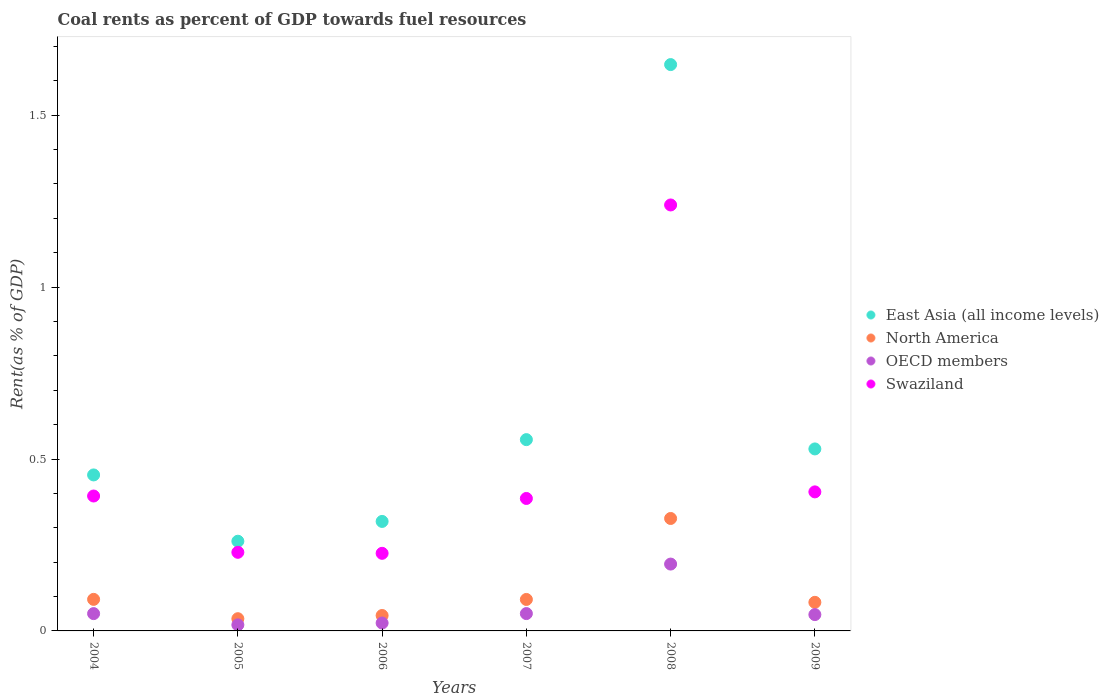How many different coloured dotlines are there?
Offer a very short reply. 4. What is the coal rent in North America in 2005?
Make the answer very short. 0.04. Across all years, what is the maximum coal rent in OECD members?
Offer a very short reply. 0.19. Across all years, what is the minimum coal rent in North America?
Offer a very short reply. 0.04. In which year was the coal rent in East Asia (all income levels) maximum?
Offer a very short reply. 2008. In which year was the coal rent in North America minimum?
Keep it short and to the point. 2005. What is the total coal rent in OECD members in the graph?
Keep it short and to the point. 0.38. What is the difference between the coal rent in OECD members in 2005 and that in 2006?
Offer a terse response. -0.01. What is the difference between the coal rent in Swaziland in 2004 and the coal rent in East Asia (all income levels) in 2007?
Your response must be concise. -0.16. What is the average coal rent in OECD members per year?
Your answer should be compact. 0.06. In the year 2004, what is the difference between the coal rent in East Asia (all income levels) and coal rent in Swaziland?
Provide a succinct answer. 0.06. In how many years, is the coal rent in East Asia (all income levels) greater than 1.1 %?
Offer a terse response. 1. What is the ratio of the coal rent in East Asia (all income levels) in 2007 to that in 2008?
Ensure brevity in your answer.  0.34. Is the coal rent in OECD members in 2007 less than that in 2009?
Your response must be concise. No. Is the difference between the coal rent in East Asia (all income levels) in 2005 and 2007 greater than the difference between the coal rent in Swaziland in 2005 and 2007?
Your response must be concise. No. What is the difference between the highest and the second highest coal rent in North America?
Provide a short and direct response. 0.24. What is the difference between the highest and the lowest coal rent in East Asia (all income levels)?
Your answer should be very brief. 1.39. Is the sum of the coal rent in OECD members in 2004 and 2007 greater than the maximum coal rent in East Asia (all income levels) across all years?
Offer a terse response. No. Is it the case that in every year, the sum of the coal rent in North America and coal rent in OECD members  is greater than the sum of coal rent in East Asia (all income levels) and coal rent in Swaziland?
Keep it short and to the point. No. Is it the case that in every year, the sum of the coal rent in North America and coal rent in Swaziland  is greater than the coal rent in East Asia (all income levels)?
Keep it short and to the point. No. Does the coal rent in North America monotonically increase over the years?
Your answer should be very brief. No. Is the coal rent in Swaziland strictly less than the coal rent in East Asia (all income levels) over the years?
Your response must be concise. Yes. How many dotlines are there?
Ensure brevity in your answer.  4. How many years are there in the graph?
Offer a terse response. 6. Are the values on the major ticks of Y-axis written in scientific E-notation?
Your response must be concise. No. Where does the legend appear in the graph?
Keep it short and to the point. Center right. How many legend labels are there?
Provide a succinct answer. 4. How are the legend labels stacked?
Provide a succinct answer. Vertical. What is the title of the graph?
Provide a succinct answer. Coal rents as percent of GDP towards fuel resources. What is the label or title of the Y-axis?
Your answer should be very brief. Rent(as % of GDP). What is the Rent(as % of GDP) of East Asia (all income levels) in 2004?
Provide a short and direct response. 0.45. What is the Rent(as % of GDP) in North America in 2004?
Provide a succinct answer. 0.09. What is the Rent(as % of GDP) of OECD members in 2004?
Provide a short and direct response. 0.05. What is the Rent(as % of GDP) of Swaziland in 2004?
Give a very brief answer. 0.39. What is the Rent(as % of GDP) in East Asia (all income levels) in 2005?
Make the answer very short. 0.26. What is the Rent(as % of GDP) of North America in 2005?
Your response must be concise. 0.04. What is the Rent(as % of GDP) in OECD members in 2005?
Give a very brief answer. 0.02. What is the Rent(as % of GDP) in Swaziland in 2005?
Your answer should be very brief. 0.23. What is the Rent(as % of GDP) in East Asia (all income levels) in 2006?
Provide a succinct answer. 0.32. What is the Rent(as % of GDP) in North America in 2006?
Your answer should be compact. 0.04. What is the Rent(as % of GDP) of OECD members in 2006?
Your answer should be compact. 0.02. What is the Rent(as % of GDP) in Swaziland in 2006?
Provide a succinct answer. 0.23. What is the Rent(as % of GDP) in East Asia (all income levels) in 2007?
Offer a very short reply. 0.56. What is the Rent(as % of GDP) of North America in 2007?
Make the answer very short. 0.09. What is the Rent(as % of GDP) in OECD members in 2007?
Offer a very short reply. 0.05. What is the Rent(as % of GDP) in Swaziland in 2007?
Offer a terse response. 0.39. What is the Rent(as % of GDP) in East Asia (all income levels) in 2008?
Keep it short and to the point. 1.65. What is the Rent(as % of GDP) of North America in 2008?
Your response must be concise. 0.33. What is the Rent(as % of GDP) in OECD members in 2008?
Provide a succinct answer. 0.19. What is the Rent(as % of GDP) of Swaziland in 2008?
Make the answer very short. 1.24. What is the Rent(as % of GDP) of East Asia (all income levels) in 2009?
Give a very brief answer. 0.53. What is the Rent(as % of GDP) in North America in 2009?
Offer a very short reply. 0.08. What is the Rent(as % of GDP) of OECD members in 2009?
Offer a very short reply. 0.05. What is the Rent(as % of GDP) of Swaziland in 2009?
Keep it short and to the point. 0.4. Across all years, what is the maximum Rent(as % of GDP) in East Asia (all income levels)?
Your answer should be compact. 1.65. Across all years, what is the maximum Rent(as % of GDP) of North America?
Offer a terse response. 0.33. Across all years, what is the maximum Rent(as % of GDP) of OECD members?
Give a very brief answer. 0.19. Across all years, what is the maximum Rent(as % of GDP) in Swaziland?
Provide a short and direct response. 1.24. Across all years, what is the minimum Rent(as % of GDP) in East Asia (all income levels)?
Your answer should be very brief. 0.26. Across all years, what is the minimum Rent(as % of GDP) of North America?
Provide a short and direct response. 0.04. Across all years, what is the minimum Rent(as % of GDP) in OECD members?
Make the answer very short. 0.02. Across all years, what is the minimum Rent(as % of GDP) of Swaziland?
Your answer should be compact. 0.23. What is the total Rent(as % of GDP) of East Asia (all income levels) in the graph?
Provide a short and direct response. 3.77. What is the total Rent(as % of GDP) of North America in the graph?
Your answer should be very brief. 0.67. What is the total Rent(as % of GDP) in OECD members in the graph?
Make the answer very short. 0.38. What is the total Rent(as % of GDP) in Swaziland in the graph?
Your answer should be compact. 2.88. What is the difference between the Rent(as % of GDP) of East Asia (all income levels) in 2004 and that in 2005?
Your response must be concise. 0.19. What is the difference between the Rent(as % of GDP) of North America in 2004 and that in 2005?
Provide a short and direct response. 0.06. What is the difference between the Rent(as % of GDP) in OECD members in 2004 and that in 2005?
Provide a succinct answer. 0.03. What is the difference between the Rent(as % of GDP) in Swaziland in 2004 and that in 2005?
Your answer should be very brief. 0.16. What is the difference between the Rent(as % of GDP) in East Asia (all income levels) in 2004 and that in 2006?
Provide a succinct answer. 0.14. What is the difference between the Rent(as % of GDP) in North America in 2004 and that in 2006?
Ensure brevity in your answer.  0.05. What is the difference between the Rent(as % of GDP) of OECD members in 2004 and that in 2006?
Offer a terse response. 0.03. What is the difference between the Rent(as % of GDP) in Swaziland in 2004 and that in 2006?
Ensure brevity in your answer.  0.17. What is the difference between the Rent(as % of GDP) of East Asia (all income levels) in 2004 and that in 2007?
Give a very brief answer. -0.1. What is the difference between the Rent(as % of GDP) in OECD members in 2004 and that in 2007?
Provide a short and direct response. -0. What is the difference between the Rent(as % of GDP) in Swaziland in 2004 and that in 2007?
Give a very brief answer. 0.01. What is the difference between the Rent(as % of GDP) of East Asia (all income levels) in 2004 and that in 2008?
Your answer should be very brief. -1.19. What is the difference between the Rent(as % of GDP) of North America in 2004 and that in 2008?
Make the answer very short. -0.24. What is the difference between the Rent(as % of GDP) in OECD members in 2004 and that in 2008?
Provide a succinct answer. -0.14. What is the difference between the Rent(as % of GDP) of Swaziland in 2004 and that in 2008?
Provide a short and direct response. -0.85. What is the difference between the Rent(as % of GDP) of East Asia (all income levels) in 2004 and that in 2009?
Offer a very short reply. -0.08. What is the difference between the Rent(as % of GDP) of North America in 2004 and that in 2009?
Ensure brevity in your answer.  0.01. What is the difference between the Rent(as % of GDP) of OECD members in 2004 and that in 2009?
Keep it short and to the point. 0. What is the difference between the Rent(as % of GDP) in Swaziland in 2004 and that in 2009?
Offer a very short reply. -0.01. What is the difference between the Rent(as % of GDP) in East Asia (all income levels) in 2005 and that in 2006?
Offer a terse response. -0.06. What is the difference between the Rent(as % of GDP) in North America in 2005 and that in 2006?
Your response must be concise. -0.01. What is the difference between the Rent(as % of GDP) in OECD members in 2005 and that in 2006?
Make the answer very short. -0.01. What is the difference between the Rent(as % of GDP) of Swaziland in 2005 and that in 2006?
Keep it short and to the point. 0. What is the difference between the Rent(as % of GDP) of East Asia (all income levels) in 2005 and that in 2007?
Offer a terse response. -0.3. What is the difference between the Rent(as % of GDP) in North America in 2005 and that in 2007?
Ensure brevity in your answer.  -0.06. What is the difference between the Rent(as % of GDP) of OECD members in 2005 and that in 2007?
Keep it short and to the point. -0.03. What is the difference between the Rent(as % of GDP) in Swaziland in 2005 and that in 2007?
Your answer should be very brief. -0.16. What is the difference between the Rent(as % of GDP) of East Asia (all income levels) in 2005 and that in 2008?
Provide a short and direct response. -1.39. What is the difference between the Rent(as % of GDP) in North America in 2005 and that in 2008?
Your answer should be compact. -0.29. What is the difference between the Rent(as % of GDP) of OECD members in 2005 and that in 2008?
Your answer should be compact. -0.18. What is the difference between the Rent(as % of GDP) of Swaziland in 2005 and that in 2008?
Keep it short and to the point. -1.01. What is the difference between the Rent(as % of GDP) of East Asia (all income levels) in 2005 and that in 2009?
Ensure brevity in your answer.  -0.27. What is the difference between the Rent(as % of GDP) of North America in 2005 and that in 2009?
Provide a succinct answer. -0.05. What is the difference between the Rent(as % of GDP) in OECD members in 2005 and that in 2009?
Offer a terse response. -0.03. What is the difference between the Rent(as % of GDP) in Swaziland in 2005 and that in 2009?
Your answer should be compact. -0.18. What is the difference between the Rent(as % of GDP) in East Asia (all income levels) in 2006 and that in 2007?
Your response must be concise. -0.24. What is the difference between the Rent(as % of GDP) of North America in 2006 and that in 2007?
Make the answer very short. -0.05. What is the difference between the Rent(as % of GDP) in OECD members in 2006 and that in 2007?
Offer a very short reply. -0.03. What is the difference between the Rent(as % of GDP) of Swaziland in 2006 and that in 2007?
Your answer should be compact. -0.16. What is the difference between the Rent(as % of GDP) in East Asia (all income levels) in 2006 and that in 2008?
Offer a terse response. -1.33. What is the difference between the Rent(as % of GDP) of North America in 2006 and that in 2008?
Provide a short and direct response. -0.28. What is the difference between the Rent(as % of GDP) in OECD members in 2006 and that in 2008?
Give a very brief answer. -0.17. What is the difference between the Rent(as % of GDP) in Swaziland in 2006 and that in 2008?
Offer a terse response. -1.01. What is the difference between the Rent(as % of GDP) of East Asia (all income levels) in 2006 and that in 2009?
Offer a terse response. -0.21. What is the difference between the Rent(as % of GDP) in North America in 2006 and that in 2009?
Offer a very short reply. -0.04. What is the difference between the Rent(as % of GDP) in OECD members in 2006 and that in 2009?
Offer a terse response. -0.02. What is the difference between the Rent(as % of GDP) of Swaziland in 2006 and that in 2009?
Provide a short and direct response. -0.18. What is the difference between the Rent(as % of GDP) of East Asia (all income levels) in 2007 and that in 2008?
Make the answer very short. -1.09. What is the difference between the Rent(as % of GDP) of North America in 2007 and that in 2008?
Make the answer very short. -0.24. What is the difference between the Rent(as % of GDP) of OECD members in 2007 and that in 2008?
Your answer should be very brief. -0.14. What is the difference between the Rent(as % of GDP) of Swaziland in 2007 and that in 2008?
Keep it short and to the point. -0.85. What is the difference between the Rent(as % of GDP) in East Asia (all income levels) in 2007 and that in 2009?
Keep it short and to the point. 0.03. What is the difference between the Rent(as % of GDP) in North America in 2007 and that in 2009?
Offer a terse response. 0.01. What is the difference between the Rent(as % of GDP) in OECD members in 2007 and that in 2009?
Provide a short and direct response. 0. What is the difference between the Rent(as % of GDP) in Swaziland in 2007 and that in 2009?
Your response must be concise. -0.02. What is the difference between the Rent(as % of GDP) in East Asia (all income levels) in 2008 and that in 2009?
Keep it short and to the point. 1.12. What is the difference between the Rent(as % of GDP) of North America in 2008 and that in 2009?
Make the answer very short. 0.24. What is the difference between the Rent(as % of GDP) in OECD members in 2008 and that in 2009?
Your answer should be very brief. 0.15. What is the difference between the Rent(as % of GDP) of Swaziland in 2008 and that in 2009?
Your answer should be very brief. 0.83. What is the difference between the Rent(as % of GDP) of East Asia (all income levels) in 2004 and the Rent(as % of GDP) of North America in 2005?
Ensure brevity in your answer.  0.42. What is the difference between the Rent(as % of GDP) of East Asia (all income levels) in 2004 and the Rent(as % of GDP) of OECD members in 2005?
Offer a terse response. 0.44. What is the difference between the Rent(as % of GDP) of East Asia (all income levels) in 2004 and the Rent(as % of GDP) of Swaziland in 2005?
Your answer should be very brief. 0.23. What is the difference between the Rent(as % of GDP) of North America in 2004 and the Rent(as % of GDP) of OECD members in 2005?
Give a very brief answer. 0.07. What is the difference between the Rent(as % of GDP) in North America in 2004 and the Rent(as % of GDP) in Swaziland in 2005?
Provide a succinct answer. -0.14. What is the difference between the Rent(as % of GDP) in OECD members in 2004 and the Rent(as % of GDP) in Swaziland in 2005?
Keep it short and to the point. -0.18. What is the difference between the Rent(as % of GDP) of East Asia (all income levels) in 2004 and the Rent(as % of GDP) of North America in 2006?
Give a very brief answer. 0.41. What is the difference between the Rent(as % of GDP) of East Asia (all income levels) in 2004 and the Rent(as % of GDP) of OECD members in 2006?
Make the answer very short. 0.43. What is the difference between the Rent(as % of GDP) of East Asia (all income levels) in 2004 and the Rent(as % of GDP) of Swaziland in 2006?
Give a very brief answer. 0.23. What is the difference between the Rent(as % of GDP) in North America in 2004 and the Rent(as % of GDP) in OECD members in 2006?
Give a very brief answer. 0.07. What is the difference between the Rent(as % of GDP) in North America in 2004 and the Rent(as % of GDP) in Swaziland in 2006?
Your answer should be compact. -0.13. What is the difference between the Rent(as % of GDP) of OECD members in 2004 and the Rent(as % of GDP) of Swaziland in 2006?
Ensure brevity in your answer.  -0.18. What is the difference between the Rent(as % of GDP) in East Asia (all income levels) in 2004 and the Rent(as % of GDP) in North America in 2007?
Your answer should be compact. 0.36. What is the difference between the Rent(as % of GDP) in East Asia (all income levels) in 2004 and the Rent(as % of GDP) in OECD members in 2007?
Ensure brevity in your answer.  0.4. What is the difference between the Rent(as % of GDP) in East Asia (all income levels) in 2004 and the Rent(as % of GDP) in Swaziland in 2007?
Make the answer very short. 0.07. What is the difference between the Rent(as % of GDP) of North America in 2004 and the Rent(as % of GDP) of OECD members in 2007?
Offer a very short reply. 0.04. What is the difference between the Rent(as % of GDP) of North America in 2004 and the Rent(as % of GDP) of Swaziland in 2007?
Keep it short and to the point. -0.29. What is the difference between the Rent(as % of GDP) in OECD members in 2004 and the Rent(as % of GDP) in Swaziland in 2007?
Ensure brevity in your answer.  -0.33. What is the difference between the Rent(as % of GDP) of East Asia (all income levels) in 2004 and the Rent(as % of GDP) of North America in 2008?
Provide a succinct answer. 0.13. What is the difference between the Rent(as % of GDP) of East Asia (all income levels) in 2004 and the Rent(as % of GDP) of OECD members in 2008?
Provide a short and direct response. 0.26. What is the difference between the Rent(as % of GDP) of East Asia (all income levels) in 2004 and the Rent(as % of GDP) of Swaziland in 2008?
Offer a terse response. -0.79. What is the difference between the Rent(as % of GDP) of North America in 2004 and the Rent(as % of GDP) of OECD members in 2008?
Your answer should be very brief. -0.1. What is the difference between the Rent(as % of GDP) in North America in 2004 and the Rent(as % of GDP) in Swaziland in 2008?
Offer a terse response. -1.15. What is the difference between the Rent(as % of GDP) in OECD members in 2004 and the Rent(as % of GDP) in Swaziland in 2008?
Offer a terse response. -1.19. What is the difference between the Rent(as % of GDP) of East Asia (all income levels) in 2004 and the Rent(as % of GDP) of North America in 2009?
Your answer should be compact. 0.37. What is the difference between the Rent(as % of GDP) in East Asia (all income levels) in 2004 and the Rent(as % of GDP) in OECD members in 2009?
Provide a short and direct response. 0.41. What is the difference between the Rent(as % of GDP) in East Asia (all income levels) in 2004 and the Rent(as % of GDP) in Swaziland in 2009?
Offer a very short reply. 0.05. What is the difference between the Rent(as % of GDP) in North America in 2004 and the Rent(as % of GDP) in OECD members in 2009?
Offer a very short reply. 0.04. What is the difference between the Rent(as % of GDP) of North America in 2004 and the Rent(as % of GDP) of Swaziland in 2009?
Your response must be concise. -0.31. What is the difference between the Rent(as % of GDP) in OECD members in 2004 and the Rent(as % of GDP) in Swaziland in 2009?
Keep it short and to the point. -0.35. What is the difference between the Rent(as % of GDP) of East Asia (all income levels) in 2005 and the Rent(as % of GDP) of North America in 2006?
Your answer should be very brief. 0.22. What is the difference between the Rent(as % of GDP) in East Asia (all income levels) in 2005 and the Rent(as % of GDP) in OECD members in 2006?
Your response must be concise. 0.24. What is the difference between the Rent(as % of GDP) of East Asia (all income levels) in 2005 and the Rent(as % of GDP) of Swaziland in 2006?
Make the answer very short. 0.04. What is the difference between the Rent(as % of GDP) in North America in 2005 and the Rent(as % of GDP) in OECD members in 2006?
Offer a terse response. 0.01. What is the difference between the Rent(as % of GDP) in North America in 2005 and the Rent(as % of GDP) in Swaziland in 2006?
Give a very brief answer. -0.19. What is the difference between the Rent(as % of GDP) of OECD members in 2005 and the Rent(as % of GDP) of Swaziland in 2006?
Your answer should be very brief. -0.21. What is the difference between the Rent(as % of GDP) of East Asia (all income levels) in 2005 and the Rent(as % of GDP) of North America in 2007?
Provide a succinct answer. 0.17. What is the difference between the Rent(as % of GDP) in East Asia (all income levels) in 2005 and the Rent(as % of GDP) in OECD members in 2007?
Give a very brief answer. 0.21. What is the difference between the Rent(as % of GDP) of East Asia (all income levels) in 2005 and the Rent(as % of GDP) of Swaziland in 2007?
Offer a very short reply. -0.12. What is the difference between the Rent(as % of GDP) in North America in 2005 and the Rent(as % of GDP) in OECD members in 2007?
Provide a short and direct response. -0.01. What is the difference between the Rent(as % of GDP) in North America in 2005 and the Rent(as % of GDP) in Swaziland in 2007?
Offer a terse response. -0.35. What is the difference between the Rent(as % of GDP) of OECD members in 2005 and the Rent(as % of GDP) of Swaziland in 2007?
Your answer should be very brief. -0.37. What is the difference between the Rent(as % of GDP) in East Asia (all income levels) in 2005 and the Rent(as % of GDP) in North America in 2008?
Keep it short and to the point. -0.07. What is the difference between the Rent(as % of GDP) of East Asia (all income levels) in 2005 and the Rent(as % of GDP) of OECD members in 2008?
Your answer should be very brief. 0.07. What is the difference between the Rent(as % of GDP) of East Asia (all income levels) in 2005 and the Rent(as % of GDP) of Swaziland in 2008?
Give a very brief answer. -0.98. What is the difference between the Rent(as % of GDP) in North America in 2005 and the Rent(as % of GDP) in OECD members in 2008?
Your response must be concise. -0.16. What is the difference between the Rent(as % of GDP) of North America in 2005 and the Rent(as % of GDP) of Swaziland in 2008?
Your response must be concise. -1.2. What is the difference between the Rent(as % of GDP) of OECD members in 2005 and the Rent(as % of GDP) of Swaziland in 2008?
Make the answer very short. -1.22. What is the difference between the Rent(as % of GDP) of East Asia (all income levels) in 2005 and the Rent(as % of GDP) of North America in 2009?
Your response must be concise. 0.18. What is the difference between the Rent(as % of GDP) of East Asia (all income levels) in 2005 and the Rent(as % of GDP) of OECD members in 2009?
Your response must be concise. 0.21. What is the difference between the Rent(as % of GDP) in East Asia (all income levels) in 2005 and the Rent(as % of GDP) in Swaziland in 2009?
Offer a very short reply. -0.14. What is the difference between the Rent(as % of GDP) of North America in 2005 and the Rent(as % of GDP) of OECD members in 2009?
Provide a short and direct response. -0.01. What is the difference between the Rent(as % of GDP) of North America in 2005 and the Rent(as % of GDP) of Swaziland in 2009?
Provide a succinct answer. -0.37. What is the difference between the Rent(as % of GDP) of OECD members in 2005 and the Rent(as % of GDP) of Swaziland in 2009?
Your answer should be compact. -0.39. What is the difference between the Rent(as % of GDP) of East Asia (all income levels) in 2006 and the Rent(as % of GDP) of North America in 2007?
Ensure brevity in your answer.  0.23. What is the difference between the Rent(as % of GDP) in East Asia (all income levels) in 2006 and the Rent(as % of GDP) in OECD members in 2007?
Your answer should be very brief. 0.27. What is the difference between the Rent(as % of GDP) in East Asia (all income levels) in 2006 and the Rent(as % of GDP) in Swaziland in 2007?
Provide a short and direct response. -0.07. What is the difference between the Rent(as % of GDP) in North America in 2006 and the Rent(as % of GDP) in OECD members in 2007?
Offer a terse response. -0.01. What is the difference between the Rent(as % of GDP) in North America in 2006 and the Rent(as % of GDP) in Swaziland in 2007?
Your answer should be compact. -0.34. What is the difference between the Rent(as % of GDP) of OECD members in 2006 and the Rent(as % of GDP) of Swaziland in 2007?
Provide a succinct answer. -0.36. What is the difference between the Rent(as % of GDP) of East Asia (all income levels) in 2006 and the Rent(as % of GDP) of North America in 2008?
Make the answer very short. -0.01. What is the difference between the Rent(as % of GDP) of East Asia (all income levels) in 2006 and the Rent(as % of GDP) of OECD members in 2008?
Your response must be concise. 0.12. What is the difference between the Rent(as % of GDP) in East Asia (all income levels) in 2006 and the Rent(as % of GDP) in Swaziland in 2008?
Make the answer very short. -0.92. What is the difference between the Rent(as % of GDP) of North America in 2006 and the Rent(as % of GDP) of OECD members in 2008?
Make the answer very short. -0.15. What is the difference between the Rent(as % of GDP) of North America in 2006 and the Rent(as % of GDP) of Swaziland in 2008?
Ensure brevity in your answer.  -1.19. What is the difference between the Rent(as % of GDP) in OECD members in 2006 and the Rent(as % of GDP) in Swaziland in 2008?
Offer a terse response. -1.22. What is the difference between the Rent(as % of GDP) of East Asia (all income levels) in 2006 and the Rent(as % of GDP) of North America in 2009?
Your response must be concise. 0.24. What is the difference between the Rent(as % of GDP) in East Asia (all income levels) in 2006 and the Rent(as % of GDP) in OECD members in 2009?
Offer a very short reply. 0.27. What is the difference between the Rent(as % of GDP) in East Asia (all income levels) in 2006 and the Rent(as % of GDP) in Swaziland in 2009?
Ensure brevity in your answer.  -0.09. What is the difference between the Rent(as % of GDP) of North America in 2006 and the Rent(as % of GDP) of OECD members in 2009?
Your answer should be very brief. -0. What is the difference between the Rent(as % of GDP) in North America in 2006 and the Rent(as % of GDP) in Swaziland in 2009?
Your response must be concise. -0.36. What is the difference between the Rent(as % of GDP) in OECD members in 2006 and the Rent(as % of GDP) in Swaziland in 2009?
Provide a succinct answer. -0.38. What is the difference between the Rent(as % of GDP) of East Asia (all income levels) in 2007 and the Rent(as % of GDP) of North America in 2008?
Offer a terse response. 0.23. What is the difference between the Rent(as % of GDP) in East Asia (all income levels) in 2007 and the Rent(as % of GDP) in OECD members in 2008?
Provide a short and direct response. 0.36. What is the difference between the Rent(as % of GDP) of East Asia (all income levels) in 2007 and the Rent(as % of GDP) of Swaziland in 2008?
Provide a short and direct response. -0.68. What is the difference between the Rent(as % of GDP) in North America in 2007 and the Rent(as % of GDP) in OECD members in 2008?
Offer a very short reply. -0.1. What is the difference between the Rent(as % of GDP) in North America in 2007 and the Rent(as % of GDP) in Swaziland in 2008?
Provide a short and direct response. -1.15. What is the difference between the Rent(as % of GDP) of OECD members in 2007 and the Rent(as % of GDP) of Swaziland in 2008?
Keep it short and to the point. -1.19. What is the difference between the Rent(as % of GDP) of East Asia (all income levels) in 2007 and the Rent(as % of GDP) of North America in 2009?
Give a very brief answer. 0.47. What is the difference between the Rent(as % of GDP) of East Asia (all income levels) in 2007 and the Rent(as % of GDP) of OECD members in 2009?
Ensure brevity in your answer.  0.51. What is the difference between the Rent(as % of GDP) of East Asia (all income levels) in 2007 and the Rent(as % of GDP) of Swaziland in 2009?
Keep it short and to the point. 0.15. What is the difference between the Rent(as % of GDP) in North America in 2007 and the Rent(as % of GDP) in OECD members in 2009?
Provide a succinct answer. 0.04. What is the difference between the Rent(as % of GDP) in North America in 2007 and the Rent(as % of GDP) in Swaziland in 2009?
Your answer should be compact. -0.31. What is the difference between the Rent(as % of GDP) in OECD members in 2007 and the Rent(as % of GDP) in Swaziland in 2009?
Make the answer very short. -0.35. What is the difference between the Rent(as % of GDP) in East Asia (all income levels) in 2008 and the Rent(as % of GDP) in North America in 2009?
Your response must be concise. 1.56. What is the difference between the Rent(as % of GDP) of East Asia (all income levels) in 2008 and the Rent(as % of GDP) of OECD members in 2009?
Provide a short and direct response. 1.6. What is the difference between the Rent(as % of GDP) of East Asia (all income levels) in 2008 and the Rent(as % of GDP) of Swaziland in 2009?
Your answer should be very brief. 1.24. What is the difference between the Rent(as % of GDP) of North America in 2008 and the Rent(as % of GDP) of OECD members in 2009?
Ensure brevity in your answer.  0.28. What is the difference between the Rent(as % of GDP) of North America in 2008 and the Rent(as % of GDP) of Swaziland in 2009?
Your response must be concise. -0.08. What is the difference between the Rent(as % of GDP) in OECD members in 2008 and the Rent(as % of GDP) in Swaziland in 2009?
Ensure brevity in your answer.  -0.21. What is the average Rent(as % of GDP) of East Asia (all income levels) per year?
Your answer should be compact. 0.63. What is the average Rent(as % of GDP) of North America per year?
Your response must be concise. 0.11. What is the average Rent(as % of GDP) in OECD members per year?
Provide a succinct answer. 0.06. What is the average Rent(as % of GDP) of Swaziland per year?
Keep it short and to the point. 0.48. In the year 2004, what is the difference between the Rent(as % of GDP) of East Asia (all income levels) and Rent(as % of GDP) of North America?
Provide a succinct answer. 0.36. In the year 2004, what is the difference between the Rent(as % of GDP) of East Asia (all income levels) and Rent(as % of GDP) of OECD members?
Your answer should be very brief. 0.4. In the year 2004, what is the difference between the Rent(as % of GDP) in East Asia (all income levels) and Rent(as % of GDP) in Swaziland?
Your answer should be very brief. 0.06. In the year 2004, what is the difference between the Rent(as % of GDP) in North America and Rent(as % of GDP) in OECD members?
Offer a terse response. 0.04. In the year 2004, what is the difference between the Rent(as % of GDP) of North America and Rent(as % of GDP) of Swaziland?
Provide a succinct answer. -0.3. In the year 2004, what is the difference between the Rent(as % of GDP) in OECD members and Rent(as % of GDP) in Swaziland?
Keep it short and to the point. -0.34. In the year 2005, what is the difference between the Rent(as % of GDP) in East Asia (all income levels) and Rent(as % of GDP) in North America?
Provide a succinct answer. 0.23. In the year 2005, what is the difference between the Rent(as % of GDP) of East Asia (all income levels) and Rent(as % of GDP) of OECD members?
Keep it short and to the point. 0.24. In the year 2005, what is the difference between the Rent(as % of GDP) of East Asia (all income levels) and Rent(as % of GDP) of Swaziland?
Provide a succinct answer. 0.03. In the year 2005, what is the difference between the Rent(as % of GDP) of North America and Rent(as % of GDP) of OECD members?
Provide a short and direct response. 0.02. In the year 2005, what is the difference between the Rent(as % of GDP) of North America and Rent(as % of GDP) of Swaziland?
Keep it short and to the point. -0.19. In the year 2005, what is the difference between the Rent(as % of GDP) in OECD members and Rent(as % of GDP) in Swaziland?
Give a very brief answer. -0.21. In the year 2006, what is the difference between the Rent(as % of GDP) in East Asia (all income levels) and Rent(as % of GDP) in North America?
Provide a succinct answer. 0.27. In the year 2006, what is the difference between the Rent(as % of GDP) of East Asia (all income levels) and Rent(as % of GDP) of OECD members?
Provide a succinct answer. 0.3. In the year 2006, what is the difference between the Rent(as % of GDP) in East Asia (all income levels) and Rent(as % of GDP) in Swaziland?
Make the answer very short. 0.09. In the year 2006, what is the difference between the Rent(as % of GDP) in North America and Rent(as % of GDP) in OECD members?
Keep it short and to the point. 0.02. In the year 2006, what is the difference between the Rent(as % of GDP) in North America and Rent(as % of GDP) in Swaziland?
Give a very brief answer. -0.18. In the year 2006, what is the difference between the Rent(as % of GDP) of OECD members and Rent(as % of GDP) of Swaziland?
Offer a terse response. -0.2. In the year 2007, what is the difference between the Rent(as % of GDP) of East Asia (all income levels) and Rent(as % of GDP) of North America?
Provide a succinct answer. 0.46. In the year 2007, what is the difference between the Rent(as % of GDP) of East Asia (all income levels) and Rent(as % of GDP) of OECD members?
Ensure brevity in your answer.  0.51. In the year 2007, what is the difference between the Rent(as % of GDP) of East Asia (all income levels) and Rent(as % of GDP) of Swaziland?
Give a very brief answer. 0.17. In the year 2007, what is the difference between the Rent(as % of GDP) of North America and Rent(as % of GDP) of OECD members?
Give a very brief answer. 0.04. In the year 2007, what is the difference between the Rent(as % of GDP) in North America and Rent(as % of GDP) in Swaziland?
Make the answer very short. -0.29. In the year 2007, what is the difference between the Rent(as % of GDP) of OECD members and Rent(as % of GDP) of Swaziland?
Your answer should be very brief. -0.33. In the year 2008, what is the difference between the Rent(as % of GDP) of East Asia (all income levels) and Rent(as % of GDP) of North America?
Ensure brevity in your answer.  1.32. In the year 2008, what is the difference between the Rent(as % of GDP) of East Asia (all income levels) and Rent(as % of GDP) of OECD members?
Provide a succinct answer. 1.45. In the year 2008, what is the difference between the Rent(as % of GDP) in East Asia (all income levels) and Rent(as % of GDP) in Swaziland?
Offer a terse response. 0.41. In the year 2008, what is the difference between the Rent(as % of GDP) in North America and Rent(as % of GDP) in OECD members?
Provide a succinct answer. 0.13. In the year 2008, what is the difference between the Rent(as % of GDP) in North America and Rent(as % of GDP) in Swaziland?
Ensure brevity in your answer.  -0.91. In the year 2008, what is the difference between the Rent(as % of GDP) of OECD members and Rent(as % of GDP) of Swaziland?
Make the answer very short. -1.04. In the year 2009, what is the difference between the Rent(as % of GDP) in East Asia (all income levels) and Rent(as % of GDP) in North America?
Provide a short and direct response. 0.45. In the year 2009, what is the difference between the Rent(as % of GDP) in East Asia (all income levels) and Rent(as % of GDP) in OECD members?
Your answer should be compact. 0.48. In the year 2009, what is the difference between the Rent(as % of GDP) of East Asia (all income levels) and Rent(as % of GDP) of Swaziland?
Provide a succinct answer. 0.12. In the year 2009, what is the difference between the Rent(as % of GDP) of North America and Rent(as % of GDP) of OECD members?
Your answer should be very brief. 0.04. In the year 2009, what is the difference between the Rent(as % of GDP) of North America and Rent(as % of GDP) of Swaziland?
Provide a succinct answer. -0.32. In the year 2009, what is the difference between the Rent(as % of GDP) in OECD members and Rent(as % of GDP) in Swaziland?
Keep it short and to the point. -0.36. What is the ratio of the Rent(as % of GDP) in East Asia (all income levels) in 2004 to that in 2005?
Offer a terse response. 1.74. What is the ratio of the Rent(as % of GDP) in North America in 2004 to that in 2005?
Offer a terse response. 2.58. What is the ratio of the Rent(as % of GDP) of OECD members in 2004 to that in 2005?
Ensure brevity in your answer.  2.86. What is the ratio of the Rent(as % of GDP) of Swaziland in 2004 to that in 2005?
Provide a short and direct response. 1.72. What is the ratio of the Rent(as % of GDP) of East Asia (all income levels) in 2004 to that in 2006?
Give a very brief answer. 1.42. What is the ratio of the Rent(as % of GDP) in North America in 2004 to that in 2006?
Provide a short and direct response. 2.05. What is the ratio of the Rent(as % of GDP) of OECD members in 2004 to that in 2006?
Offer a very short reply. 2.19. What is the ratio of the Rent(as % of GDP) in Swaziland in 2004 to that in 2006?
Provide a succinct answer. 1.74. What is the ratio of the Rent(as % of GDP) of East Asia (all income levels) in 2004 to that in 2007?
Provide a succinct answer. 0.82. What is the ratio of the Rent(as % of GDP) in North America in 2004 to that in 2007?
Give a very brief answer. 1. What is the ratio of the Rent(as % of GDP) of OECD members in 2004 to that in 2007?
Ensure brevity in your answer.  1. What is the ratio of the Rent(as % of GDP) in Swaziland in 2004 to that in 2007?
Ensure brevity in your answer.  1.02. What is the ratio of the Rent(as % of GDP) of East Asia (all income levels) in 2004 to that in 2008?
Ensure brevity in your answer.  0.28. What is the ratio of the Rent(as % of GDP) in North America in 2004 to that in 2008?
Provide a short and direct response. 0.28. What is the ratio of the Rent(as % of GDP) of OECD members in 2004 to that in 2008?
Your answer should be very brief. 0.26. What is the ratio of the Rent(as % of GDP) of Swaziland in 2004 to that in 2008?
Provide a succinct answer. 0.32. What is the ratio of the Rent(as % of GDP) in North America in 2004 to that in 2009?
Keep it short and to the point. 1.1. What is the ratio of the Rent(as % of GDP) of OECD members in 2004 to that in 2009?
Your answer should be compact. 1.06. What is the ratio of the Rent(as % of GDP) of Swaziland in 2004 to that in 2009?
Provide a short and direct response. 0.97. What is the ratio of the Rent(as % of GDP) of East Asia (all income levels) in 2005 to that in 2006?
Make the answer very short. 0.82. What is the ratio of the Rent(as % of GDP) in North America in 2005 to that in 2006?
Offer a very short reply. 0.79. What is the ratio of the Rent(as % of GDP) of OECD members in 2005 to that in 2006?
Provide a succinct answer. 0.77. What is the ratio of the Rent(as % of GDP) in East Asia (all income levels) in 2005 to that in 2007?
Your response must be concise. 0.47. What is the ratio of the Rent(as % of GDP) in North America in 2005 to that in 2007?
Offer a very short reply. 0.39. What is the ratio of the Rent(as % of GDP) in OECD members in 2005 to that in 2007?
Keep it short and to the point. 0.35. What is the ratio of the Rent(as % of GDP) in Swaziland in 2005 to that in 2007?
Provide a succinct answer. 0.59. What is the ratio of the Rent(as % of GDP) in East Asia (all income levels) in 2005 to that in 2008?
Provide a succinct answer. 0.16. What is the ratio of the Rent(as % of GDP) in North America in 2005 to that in 2008?
Provide a succinct answer. 0.11. What is the ratio of the Rent(as % of GDP) of OECD members in 2005 to that in 2008?
Your answer should be very brief. 0.09. What is the ratio of the Rent(as % of GDP) of Swaziland in 2005 to that in 2008?
Make the answer very short. 0.18. What is the ratio of the Rent(as % of GDP) of East Asia (all income levels) in 2005 to that in 2009?
Ensure brevity in your answer.  0.49. What is the ratio of the Rent(as % of GDP) of North America in 2005 to that in 2009?
Keep it short and to the point. 0.43. What is the ratio of the Rent(as % of GDP) of OECD members in 2005 to that in 2009?
Keep it short and to the point. 0.37. What is the ratio of the Rent(as % of GDP) of Swaziland in 2005 to that in 2009?
Offer a very short reply. 0.57. What is the ratio of the Rent(as % of GDP) in East Asia (all income levels) in 2006 to that in 2007?
Provide a succinct answer. 0.57. What is the ratio of the Rent(as % of GDP) in North America in 2006 to that in 2007?
Give a very brief answer. 0.49. What is the ratio of the Rent(as % of GDP) in OECD members in 2006 to that in 2007?
Provide a short and direct response. 0.46. What is the ratio of the Rent(as % of GDP) of Swaziland in 2006 to that in 2007?
Offer a very short reply. 0.59. What is the ratio of the Rent(as % of GDP) in East Asia (all income levels) in 2006 to that in 2008?
Provide a succinct answer. 0.19. What is the ratio of the Rent(as % of GDP) in North America in 2006 to that in 2008?
Provide a short and direct response. 0.14. What is the ratio of the Rent(as % of GDP) of OECD members in 2006 to that in 2008?
Ensure brevity in your answer.  0.12. What is the ratio of the Rent(as % of GDP) in Swaziland in 2006 to that in 2008?
Provide a succinct answer. 0.18. What is the ratio of the Rent(as % of GDP) in East Asia (all income levels) in 2006 to that in 2009?
Make the answer very short. 0.6. What is the ratio of the Rent(as % of GDP) of North America in 2006 to that in 2009?
Offer a very short reply. 0.54. What is the ratio of the Rent(as % of GDP) of OECD members in 2006 to that in 2009?
Ensure brevity in your answer.  0.48. What is the ratio of the Rent(as % of GDP) in Swaziland in 2006 to that in 2009?
Ensure brevity in your answer.  0.56. What is the ratio of the Rent(as % of GDP) of East Asia (all income levels) in 2007 to that in 2008?
Your response must be concise. 0.34. What is the ratio of the Rent(as % of GDP) of North America in 2007 to that in 2008?
Offer a terse response. 0.28. What is the ratio of the Rent(as % of GDP) of OECD members in 2007 to that in 2008?
Offer a very short reply. 0.26. What is the ratio of the Rent(as % of GDP) in Swaziland in 2007 to that in 2008?
Give a very brief answer. 0.31. What is the ratio of the Rent(as % of GDP) in East Asia (all income levels) in 2007 to that in 2009?
Provide a short and direct response. 1.05. What is the ratio of the Rent(as % of GDP) in North America in 2007 to that in 2009?
Your response must be concise. 1.1. What is the ratio of the Rent(as % of GDP) in OECD members in 2007 to that in 2009?
Offer a terse response. 1.06. What is the ratio of the Rent(as % of GDP) of Swaziland in 2007 to that in 2009?
Offer a terse response. 0.95. What is the ratio of the Rent(as % of GDP) of East Asia (all income levels) in 2008 to that in 2009?
Offer a very short reply. 3.11. What is the ratio of the Rent(as % of GDP) in North America in 2008 to that in 2009?
Give a very brief answer. 3.93. What is the ratio of the Rent(as % of GDP) of OECD members in 2008 to that in 2009?
Ensure brevity in your answer.  4.09. What is the ratio of the Rent(as % of GDP) of Swaziland in 2008 to that in 2009?
Offer a very short reply. 3.06. What is the difference between the highest and the second highest Rent(as % of GDP) in East Asia (all income levels)?
Keep it short and to the point. 1.09. What is the difference between the highest and the second highest Rent(as % of GDP) of North America?
Provide a short and direct response. 0.24. What is the difference between the highest and the second highest Rent(as % of GDP) in OECD members?
Offer a very short reply. 0.14. What is the difference between the highest and the second highest Rent(as % of GDP) of Swaziland?
Give a very brief answer. 0.83. What is the difference between the highest and the lowest Rent(as % of GDP) in East Asia (all income levels)?
Offer a very short reply. 1.39. What is the difference between the highest and the lowest Rent(as % of GDP) of North America?
Offer a very short reply. 0.29. What is the difference between the highest and the lowest Rent(as % of GDP) of OECD members?
Provide a succinct answer. 0.18. What is the difference between the highest and the lowest Rent(as % of GDP) in Swaziland?
Give a very brief answer. 1.01. 